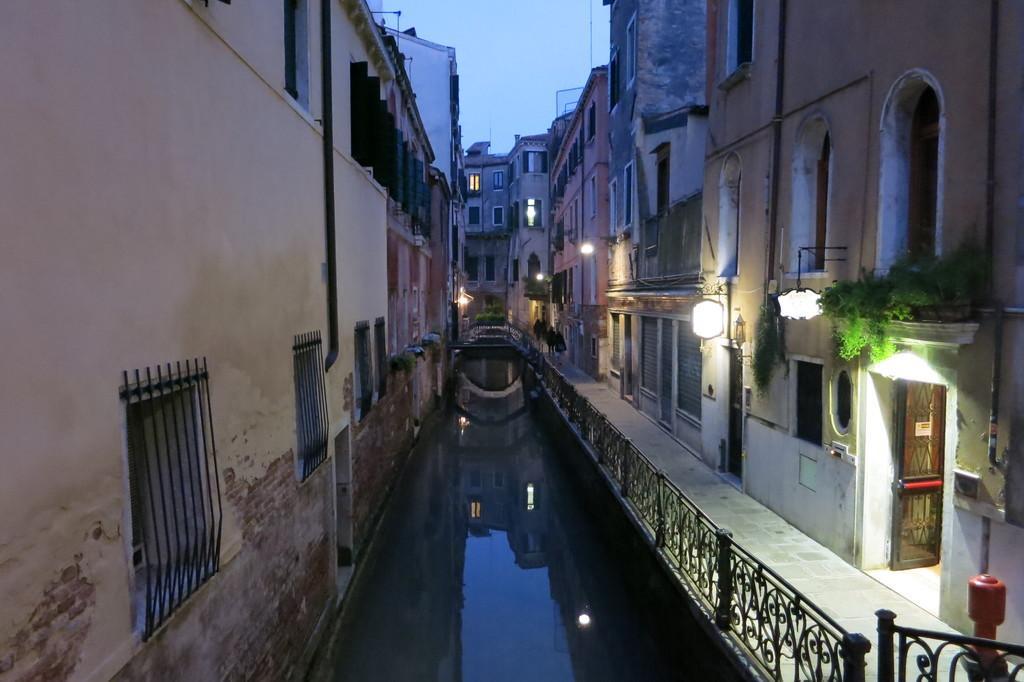How would you summarize this image in a sentence or two? In this image, we can see water, there are some buildings, we can see some windows, there is a fence, at the top there is a sky. 